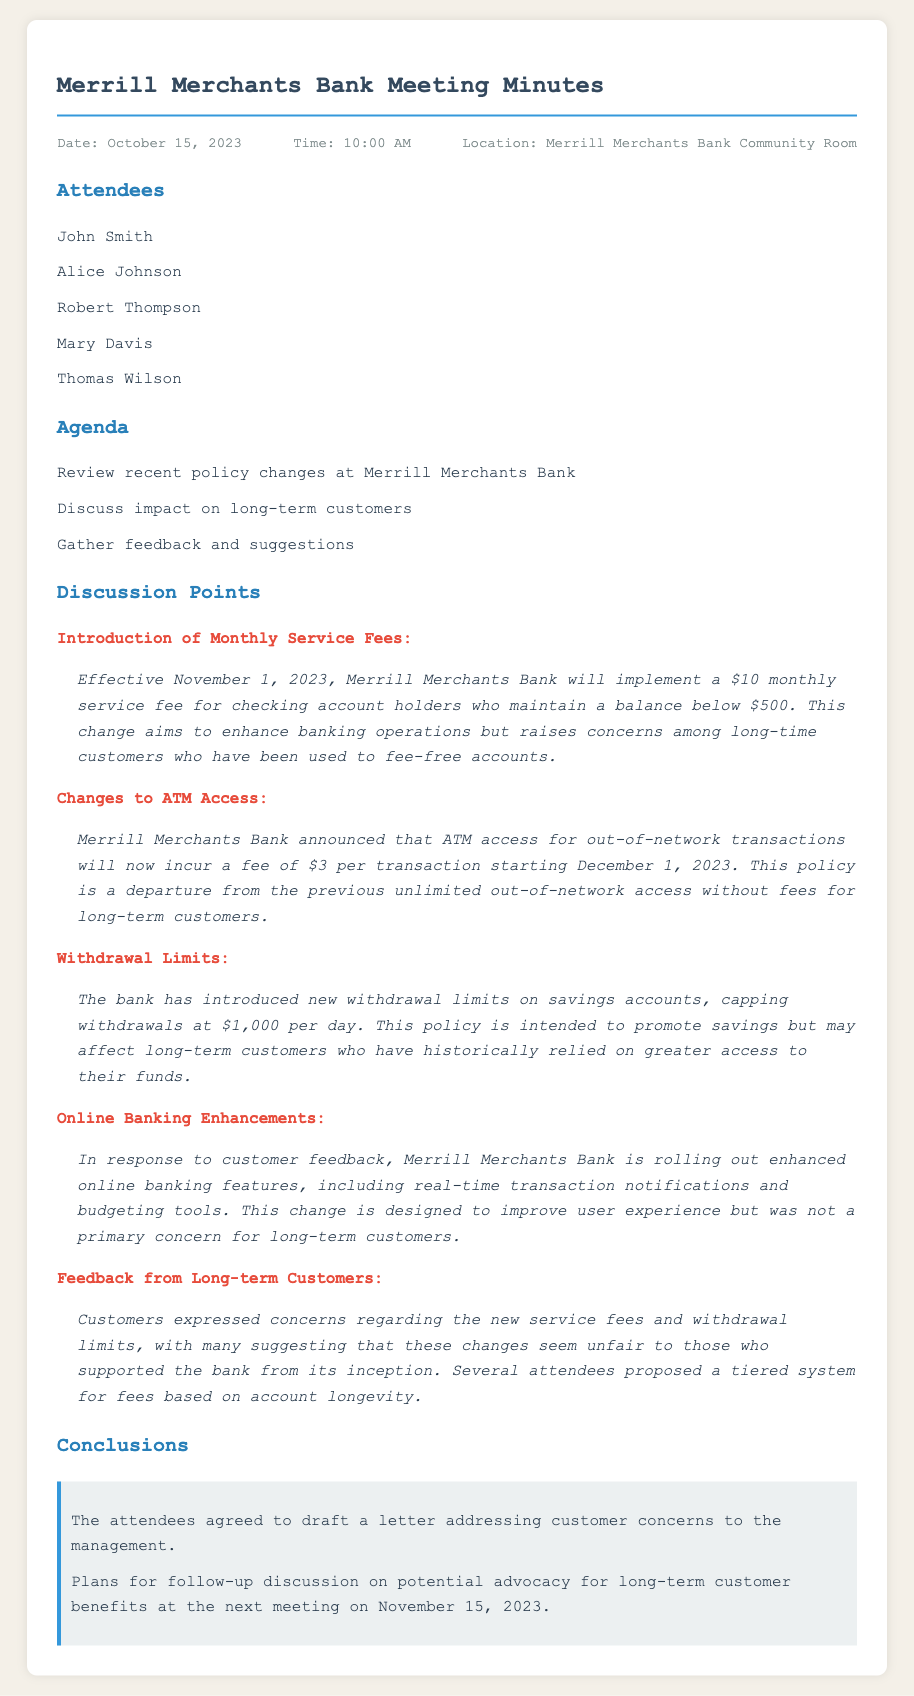What is the date of the meeting? The date of the meeting is listed at the top of the document in the header info section.
Answer: October 15, 2023 What will be the monthly service fee starting November 1, 2023? The document states the new fee that will be implemented for checking account holders regarding their account balance.
Answer: $10 What is the fee for out-of-network ATM transactions starting December 1, 2023? The fee for out-of-network transactions is explicitly described in the discussion points section of the document.
Answer: $3 What is the new daily withdrawal limit for savings accounts? The document provides specific information about the withdrawal limits in the section discussing changes to policies.
Answer: $1,000 What was one of the primary concerns raised by long-term customers? Long-term customers expressed their feelings about the impact of new fees and limits during the feedback discussion.
Answer: Unfair What is one enhancement being rolled out for online banking? The document mentions specific improvements to online banking that are being introduced based on customer feedback.
Answer: Real-time transaction notifications When is the next meeting scheduled for follow-up discussion? The date for the next meeting is given in the conclusions section, discussing plans for future discussions.
Answer: November 15, 2023 